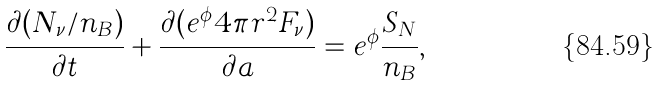<formula> <loc_0><loc_0><loc_500><loc_500>\frac { \partial ( { N _ { \nu } / n _ { B } ) } } { \partial t } + { \frac { \partial ( e ^ { \phi } 4 \pi r ^ { 2 } F _ { \nu } ) } { \partial a } } = e ^ { \phi } \frac { S _ { N } } { n _ { B } } ,</formula> 